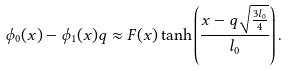Convert formula to latex. <formula><loc_0><loc_0><loc_500><loc_500>\phi _ { 0 } ( x ) - \phi _ { 1 } ( x ) q \approx F ( x ) \tanh \left ( \frac { x - q \sqrt { \frac { 3 l _ { 0 } } { 4 } } } { l _ { 0 } } \right ) .</formula> 